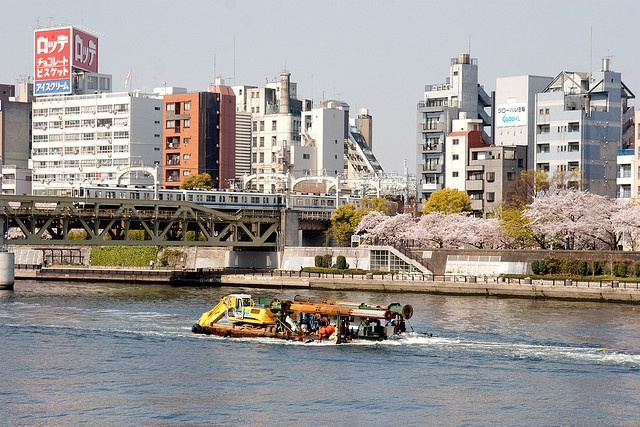Describe the objects in this image and their specific colors. I can see boat in lightgray, black, maroon, darkgray, and gray tones, train in lightgray, darkgray, gray, white, and black tones, people in lightgray, black, maroon, brown, and gray tones, people in lightgray, black, brown, and blue tones, and people in lightgray, white, black, and gray tones in this image. 